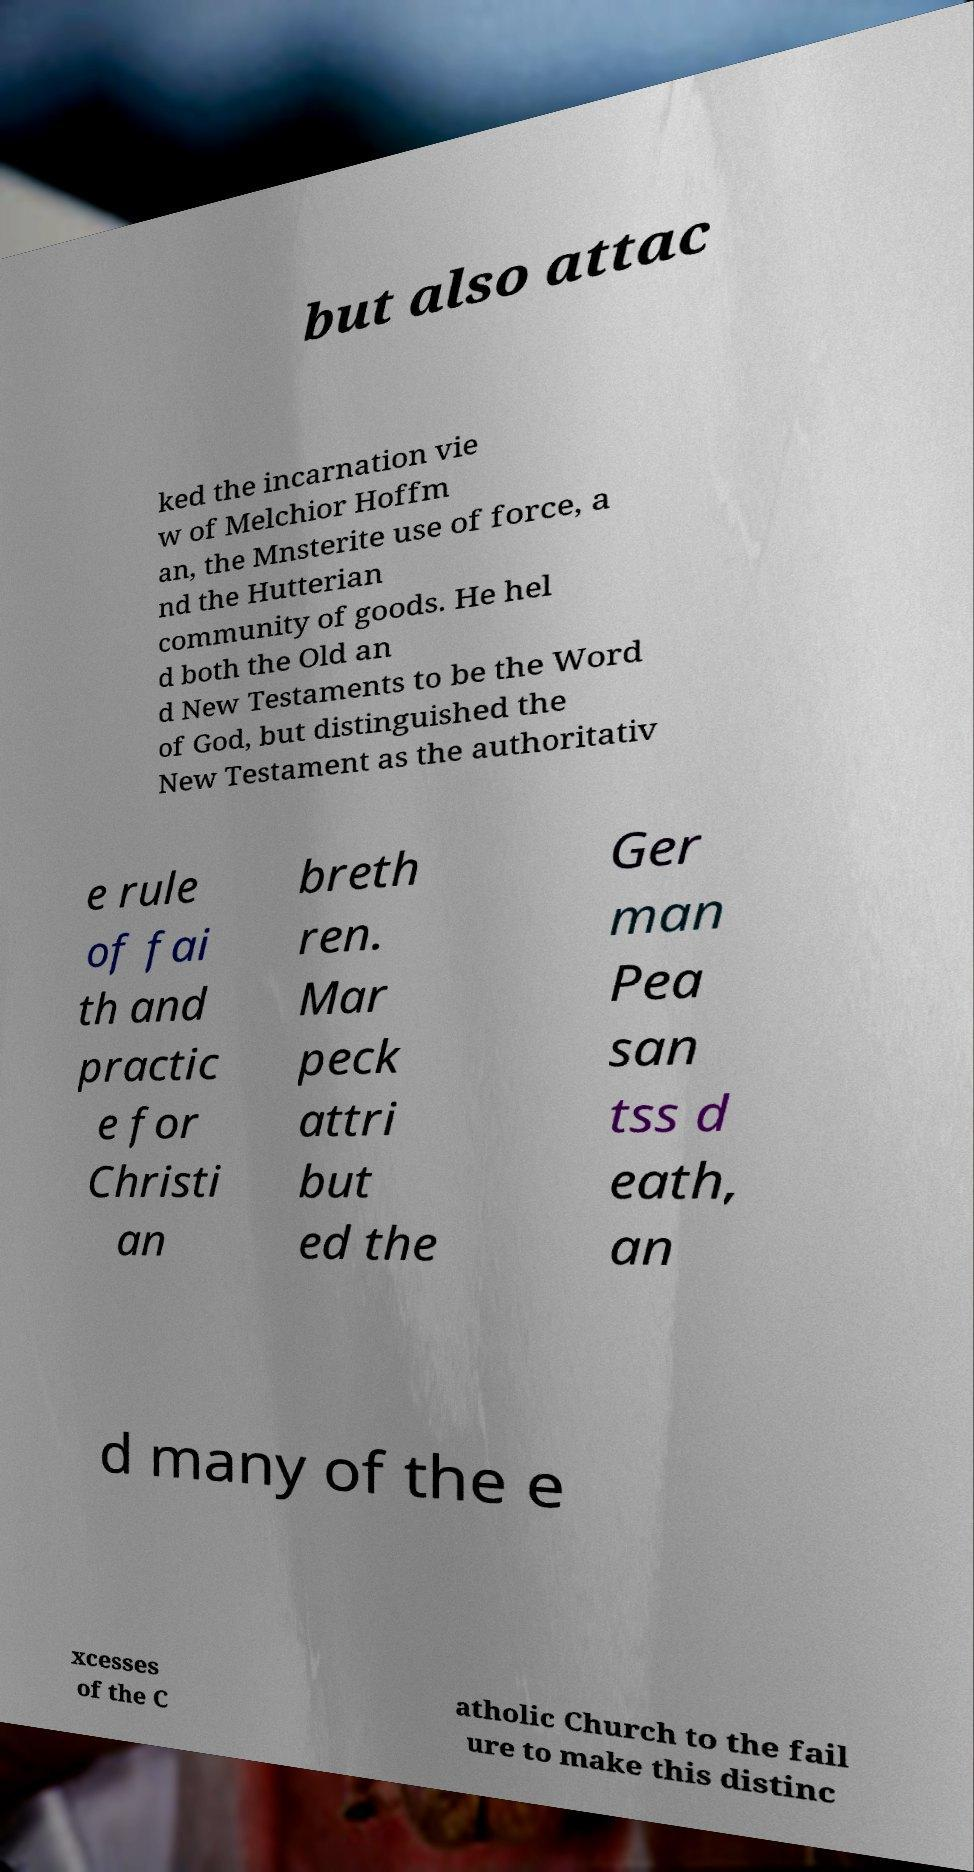Can you accurately transcribe the text from the provided image for me? but also attac ked the incarnation vie w of Melchior Hoffm an, the Mnsterite use of force, a nd the Hutterian community of goods. He hel d both the Old an d New Testaments to be the Word of God, but distinguished the New Testament as the authoritativ e rule of fai th and practic e for Christi an breth ren. Mar peck attri but ed the Ger man Pea san tss d eath, an d many of the e xcesses of the C atholic Church to the fail ure to make this distinc 